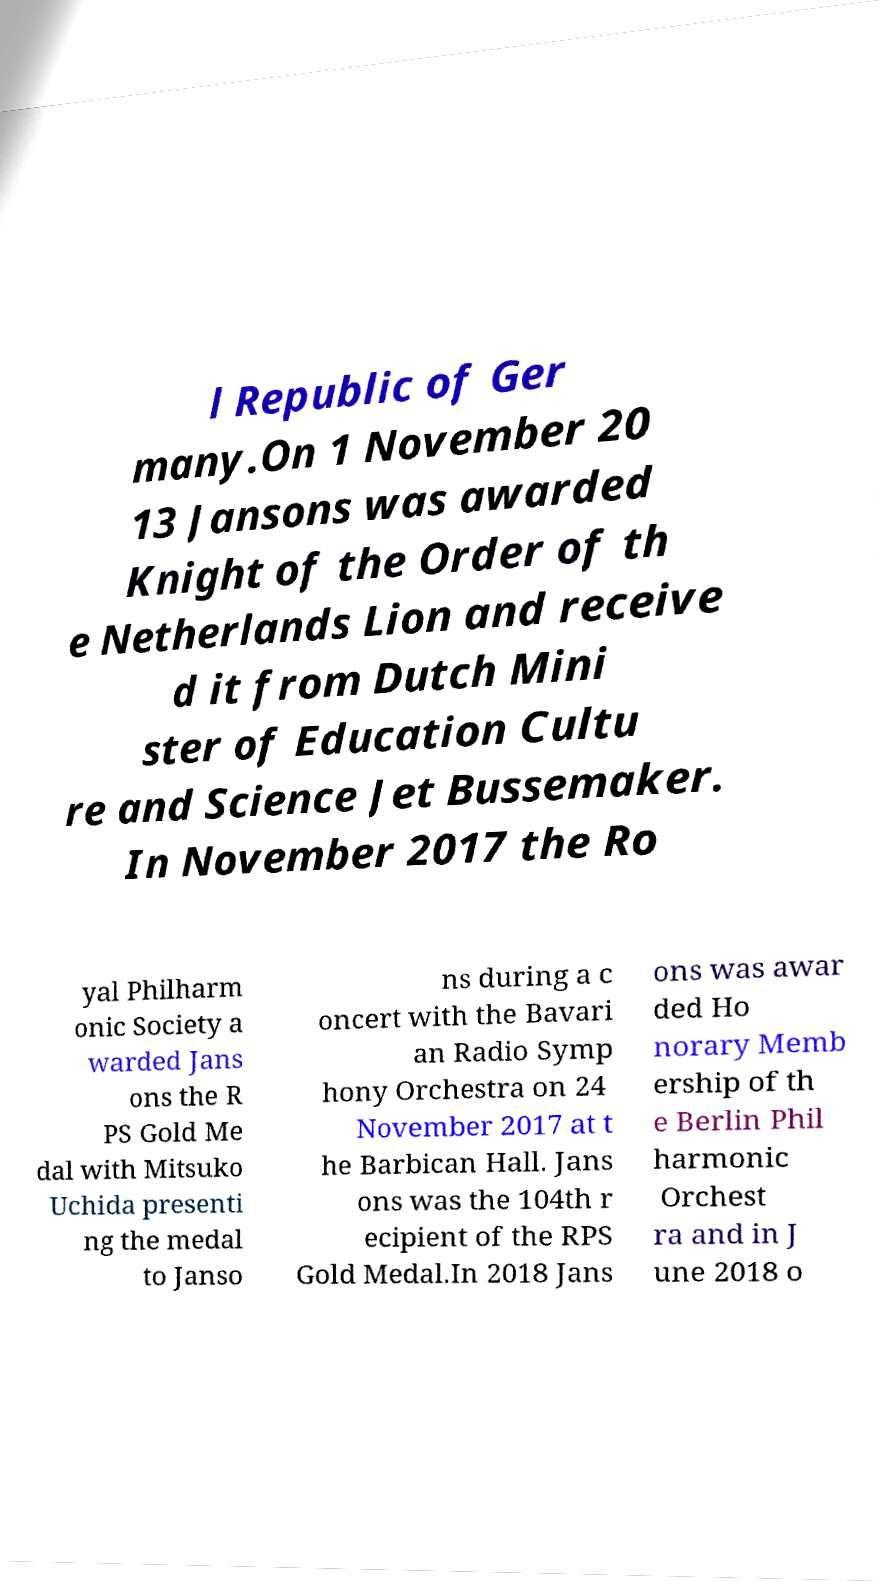What messages or text are displayed in this image? I need them in a readable, typed format. l Republic of Ger many.On 1 November 20 13 Jansons was awarded Knight of the Order of th e Netherlands Lion and receive d it from Dutch Mini ster of Education Cultu re and Science Jet Bussemaker. In November 2017 the Ro yal Philharm onic Society a warded Jans ons the R PS Gold Me dal with Mitsuko Uchida presenti ng the medal to Janso ns during a c oncert with the Bavari an Radio Symp hony Orchestra on 24 November 2017 at t he Barbican Hall. Jans ons was the 104th r ecipient of the RPS Gold Medal.In 2018 Jans ons was awar ded Ho norary Memb ership of th e Berlin Phil harmonic Orchest ra and in J une 2018 o 